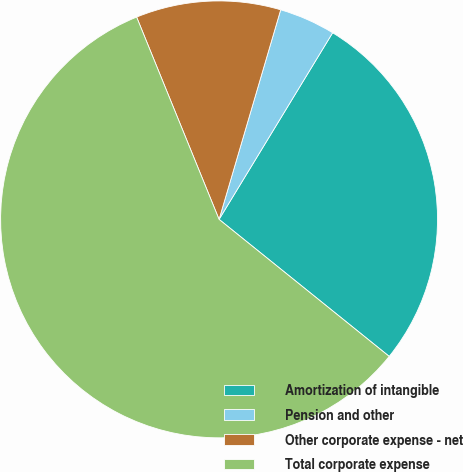<chart> <loc_0><loc_0><loc_500><loc_500><pie_chart><fcel>Amortization of intangible<fcel>Pension and other<fcel>Other corporate expense - net<fcel>Total corporate expense<nl><fcel>27.09%<fcel>4.15%<fcel>10.71%<fcel>58.05%<nl></chart> 